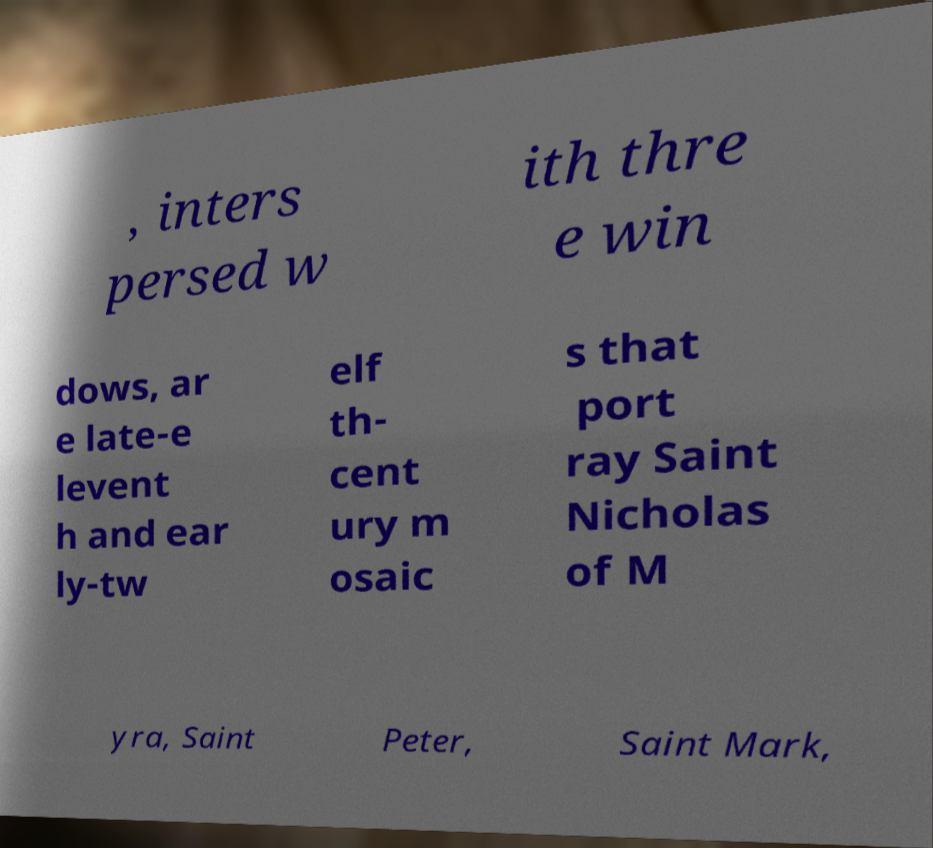I need the written content from this picture converted into text. Can you do that? , inters persed w ith thre e win dows, ar e late-e levent h and ear ly-tw elf th- cent ury m osaic s that port ray Saint Nicholas of M yra, Saint Peter, Saint Mark, 